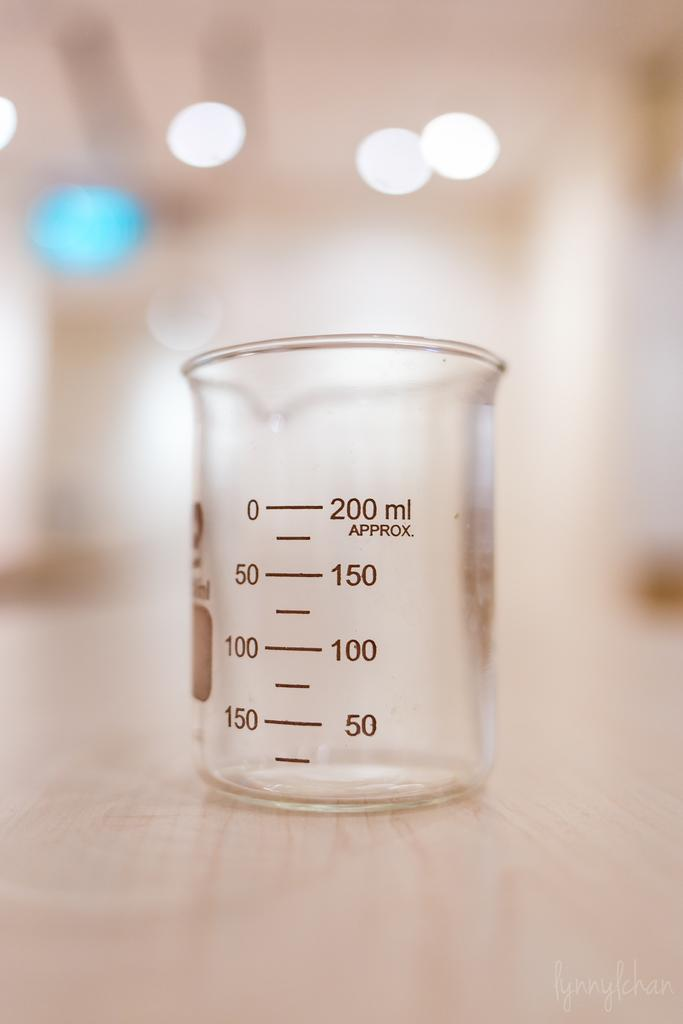<image>
Give a short and clear explanation of the subsequent image. a cup that has the number 200 on it 